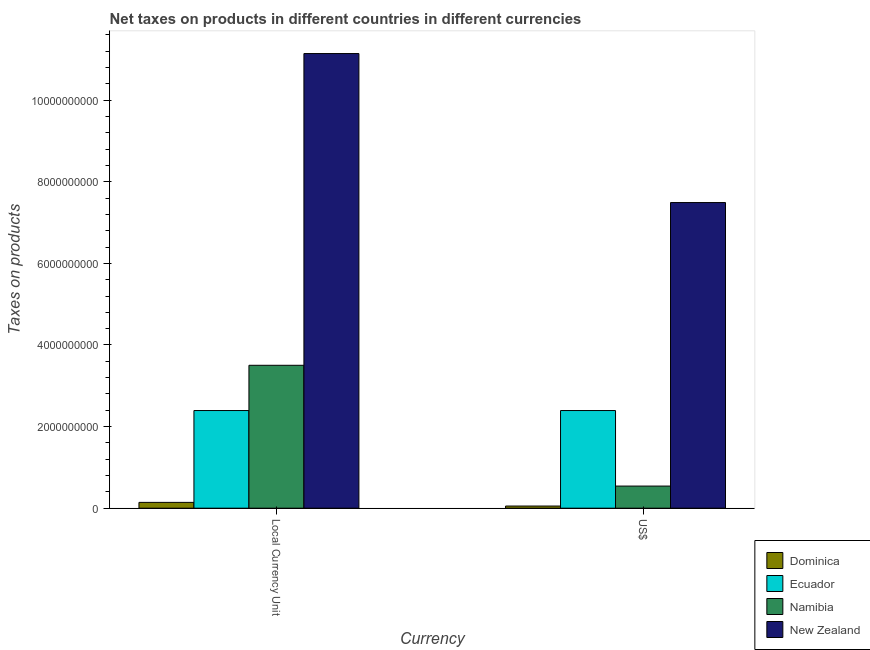How many different coloured bars are there?
Offer a very short reply. 4. How many groups of bars are there?
Provide a succinct answer. 2. Are the number of bars per tick equal to the number of legend labels?
Your answer should be compact. Yes. Are the number of bars on each tick of the X-axis equal?
Offer a terse response. Yes. What is the label of the 2nd group of bars from the left?
Offer a very short reply. US$. What is the net taxes in constant 2005 us$ in Namibia?
Provide a succinct answer. 3.50e+09. Across all countries, what is the maximum net taxes in constant 2005 us$?
Ensure brevity in your answer.  1.11e+1. Across all countries, what is the minimum net taxes in us$?
Provide a succinct answer. 5.27e+07. In which country was the net taxes in us$ maximum?
Provide a succinct answer. New Zealand. In which country was the net taxes in us$ minimum?
Your response must be concise. Dominica. What is the total net taxes in us$ in the graph?
Give a very brief answer. 1.05e+1. What is the difference between the net taxes in constant 2005 us$ in Dominica and that in New Zealand?
Make the answer very short. -1.10e+1. What is the difference between the net taxes in constant 2005 us$ in Ecuador and the net taxes in us$ in Dominica?
Offer a terse response. 2.34e+09. What is the average net taxes in constant 2005 us$ per country?
Give a very brief answer. 4.30e+09. What is the difference between the net taxes in constant 2005 us$ and net taxes in us$ in Dominica?
Your answer should be compact. 8.96e+07. What is the ratio of the net taxes in constant 2005 us$ in Ecuador to that in Dominica?
Give a very brief answer. 16.83. In how many countries, is the net taxes in constant 2005 us$ greater than the average net taxes in constant 2005 us$ taken over all countries?
Your answer should be very brief. 1. What does the 4th bar from the left in US$ represents?
Offer a very short reply. New Zealand. What does the 2nd bar from the right in US$ represents?
Provide a succinct answer. Namibia. How many countries are there in the graph?
Your answer should be very brief. 4. Does the graph contain grids?
Provide a succinct answer. No. Where does the legend appear in the graph?
Keep it short and to the point. Bottom right. How are the legend labels stacked?
Ensure brevity in your answer.  Vertical. What is the title of the graph?
Give a very brief answer. Net taxes on products in different countries in different currencies. Does "Virgin Islands" appear as one of the legend labels in the graph?
Offer a very short reply. No. What is the label or title of the X-axis?
Make the answer very short. Currency. What is the label or title of the Y-axis?
Your response must be concise. Taxes on products. What is the Taxes on products of Dominica in Local Currency Unit?
Offer a terse response. 1.42e+08. What is the Taxes on products of Ecuador in Local Currency Unit?
Offer a terse response. 2.39e+09. What is the Taxes on products of Namibia in Local Currency Unit?
Ensure brevity in your answer.  3.50e+09. What is the Taxes on products of New Zealand in Local Currency Unit?
Keep it short and to the point. 1.11e+1. What is the Taxes on products of Dominica in US$?
Your response must be concise. 5.27e+07. What is the Taxes on products in Ecuador in US$?
Give a very brief answer. 2.39e+09. What is the Taxes on products of Namibia in US$?
Make the answer very short. 5.42e+08. What is the Taxes on products of New Zealand in US$?
Provide a succinct answer. 7.49e+09. Across all Currency, what is the maximum Taxes on products of Dominica?
Make the answer very short. 1.42e+08. Across all Currency, what is the maximum Taxes on products in Ecuador?
Give a very brief answer. 2.39e+09. Across all Currency, what is the maximum Taxes on products of Namibia?
Provide a succinct answer. 3.50e+09. Across all Currency, what is the maximum Taxes on products of New Zealand?
Give a very brief answer. 1.11e+1. Across all Currency, what is the minimum Taxes on products of Dominica?
Your answer should be compact. 5.27e+07. Across all Currency, what is the minimum Taxes on products in Ecuador?
Offer a terse response. 2.39e+09. Across all Currency, what is the minimum Taxes on products in Namibia?
Give a very brief answer. 5.42e+08. Across all Currency, what is the minimum Taxes on products of New Zealand?
Your response must be concise. 7.49e+09. What is the total Taxes on products of Dominica in the graph?
Your response must be concise. 1.95e+08. What is the total Taxes on products of Ecuador in the graph?
Make the answer very short. 4.79e+09. What is the total Taxes on products in Namibia in the graph?
Provide a succinct answer. 4.04e+09. What is the total Taxes on products of New Zealand in the graph?
Give a very brief answer. 1.86e+1. What is the difference between the Taxes on products in Dominica in Local Currency Unit and that in US$?
Your answer should be very brief. 8.96e+07. What is the difference between the Taxes on products of Namibia in Local Currency Unit and that in US$?
Give a very brief answer. 2.96e+09. What is the difference between the Taxes on products of New Zealand in Local Currency Unit and that in US$?
Your response must be concise. 3.65e+09. What is the difference between the Taxes on products of Dominica in Local Currency Unit and the Taxes on products of Ecuador in US$?
Provide a short and direct response. -2.25e+09. What is the difference between the Taxes on products in Dominica in Local Currency Unit and the Taxes on products in Namibia in US$?
Ensure brevity in your answer.  -4.00e+08. What is the difference between the Taxes on products of Dominica in Local Currency Unit and the Taxes on products of New Zealand in US$?
Make the answer very short. -7.35e+09. What is the difference between the Taxes on products of Ecuador in Local Currency Unit and the Taxes on products of Namibia in US$?
Provide a short and direct response. 1.85e+09. What is the difference between the Taxes on products in Ecuador in Local Currency Unit and the Taxes on products in New Zealand in US$?
Give a very brief answer. -5.10e+09. What is the difference between the Taxes on products of Namibia in Local Currency Unit and the Taxes on products of New Zealand in US$?
Provide a succinct answer. -3.99e+09. What is the average Taxes on products in Dominica per Currency?
Give a very brief answer. 9.75e+07. What is the average Taxes on products in Ecuador per Currency?
Offer a very short reply. 2.39e+09. What is the average Taxes on products of Namibia per Currency?
Make the answer very short. 2.02e+09. What is the average Taxes on products in New Zealand per Currency?
Offer a very short reply. 9.32e+09. What is the difference between the Taxes on products of Dominica and Taxes on products of Ecuador in Local Currency Unit?
Offer a terse response. -2.25e+09. What is the difference between the Taxes on products in Dominica and Taxes on products in Namibia in Local Currency Unit?
Offer a terse response. -3.36e+09. What is the difference between the Taxes on products in Dominica and Taxes on products in New Zealand in Local Currency Unit?
Your response must be concise. -1.10e+1. What is the difference between the Taxes on products in Ecuador and Taxes on products in Namibia in Local Currency Unit?
Your response must be concise. -1.11e+09. What is the difference between the Taxes on products of Ecuador and Taxes on products of New Zealand in Local Currency Unit?
Your answer should be very brief. -8.75e+09. What is the difference between the Taxes on products of Namibia and Taxes on products of New Zealand in Local Currency Unit?
Your answer should be compact. -7.64e+09. What is the difference between the Taxes on products of Dominica and Taxes on products of Ecuador in US$?
Keep it short and to the point. -2.34e+09. What is the difference between the Taxes on products in Dominica and Taxes on products in Namibia in US$?
Provide a short and direct response. -4.89e+08. What is the difference between the Taxes on products in Dominica and Taxes on products in New Zealand in US$?
Offer a very short reply. -7.44e+09. What is the difference between the Taxes on products in Ecuador and Taxes on products in Namibia in US$?
Provide a short and direct response. 1.85e+09. What is the difference between the Taxes on products of Ecuador and Taxes on products of New Zealand in US$?
Make the answer very short. -5.10e+09. What is the difference between the Taxes on products in Namibia and Taxes on products in New Zealand in US$?
Your answer should be compact. -6.95e+09. What is the ratio of the Taxes on products in Dominica in Local Currency Unit to that in US$?
Give a very brief answer. 2.7. What is the ratio of the Taxes on products of Ecuador in Local Currency Unit to that in US$?
Offer a very short reply. 1. What is the ratio of the Taxes on products in Namibia in Local Currency Unit to that in US$?
Provide a short and direct response. 6.46. What is the ratio of the Taxes on products of New Zealand in Local Currency Unit to that in US$?
Your answer should be compact. 1.49. What is the difference between the highest and the second highest Taxes on products of Dominica?
Provide a short and direct response. 8.96e+07. What is the difference between the highest and the second highest Taxes on products in Ecuador?
Make the answer very short. 0. What is the difference between the highest and the second highest Taxes on products of Namibia?
Keep it short and to the point. 2.96e+09. What is the difference between the highest and the second highest Taxes on products of New Zealand?
Keep it short and to the point. 3.65e+09. What is the difference between the highest and the lowest Taxes on products in Dominica?
Your response must be concise. 8.96e+07. What is the difference between the highest and the lowest Taxes on products of Namibia?
Your response must be concise. 2.96e+09. What is the difference between the highest and the lowest Taxes on products of New Zealand?
Your response must be concise. 3.65e+09. 